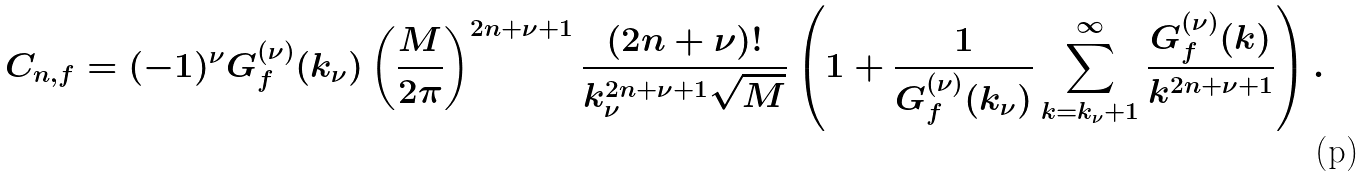Convert formula to latex. <formula><loc_0><loc_0><loc_500><loc_500>C _ { n , f } = ( - 1 ) ^ { \nu } G _ { f } ^ { ( \nu ) } ( k _ { \nu } ) \left ( \frac { M } { 2 \pi } \right ) ^ { 2 n + \nu + 1 } \frac { ( 2 n + \nu ) ! } { k _ { \nu } ^ { 2 n + \nu + 1 } \sqrt { M } } \left ( 1 + \frac { 1 } { G _ { f } ^ { ( \nu ) } ( k _ { \nu } ) } \sum _ { k = k _ { \nu } + 1 } ^ { \infty } \frac { G _ { f } ^ { ( \nu ) } ( k ) } { k ^ { 2 n + \nu + 1 } } \right ) .</formula> 